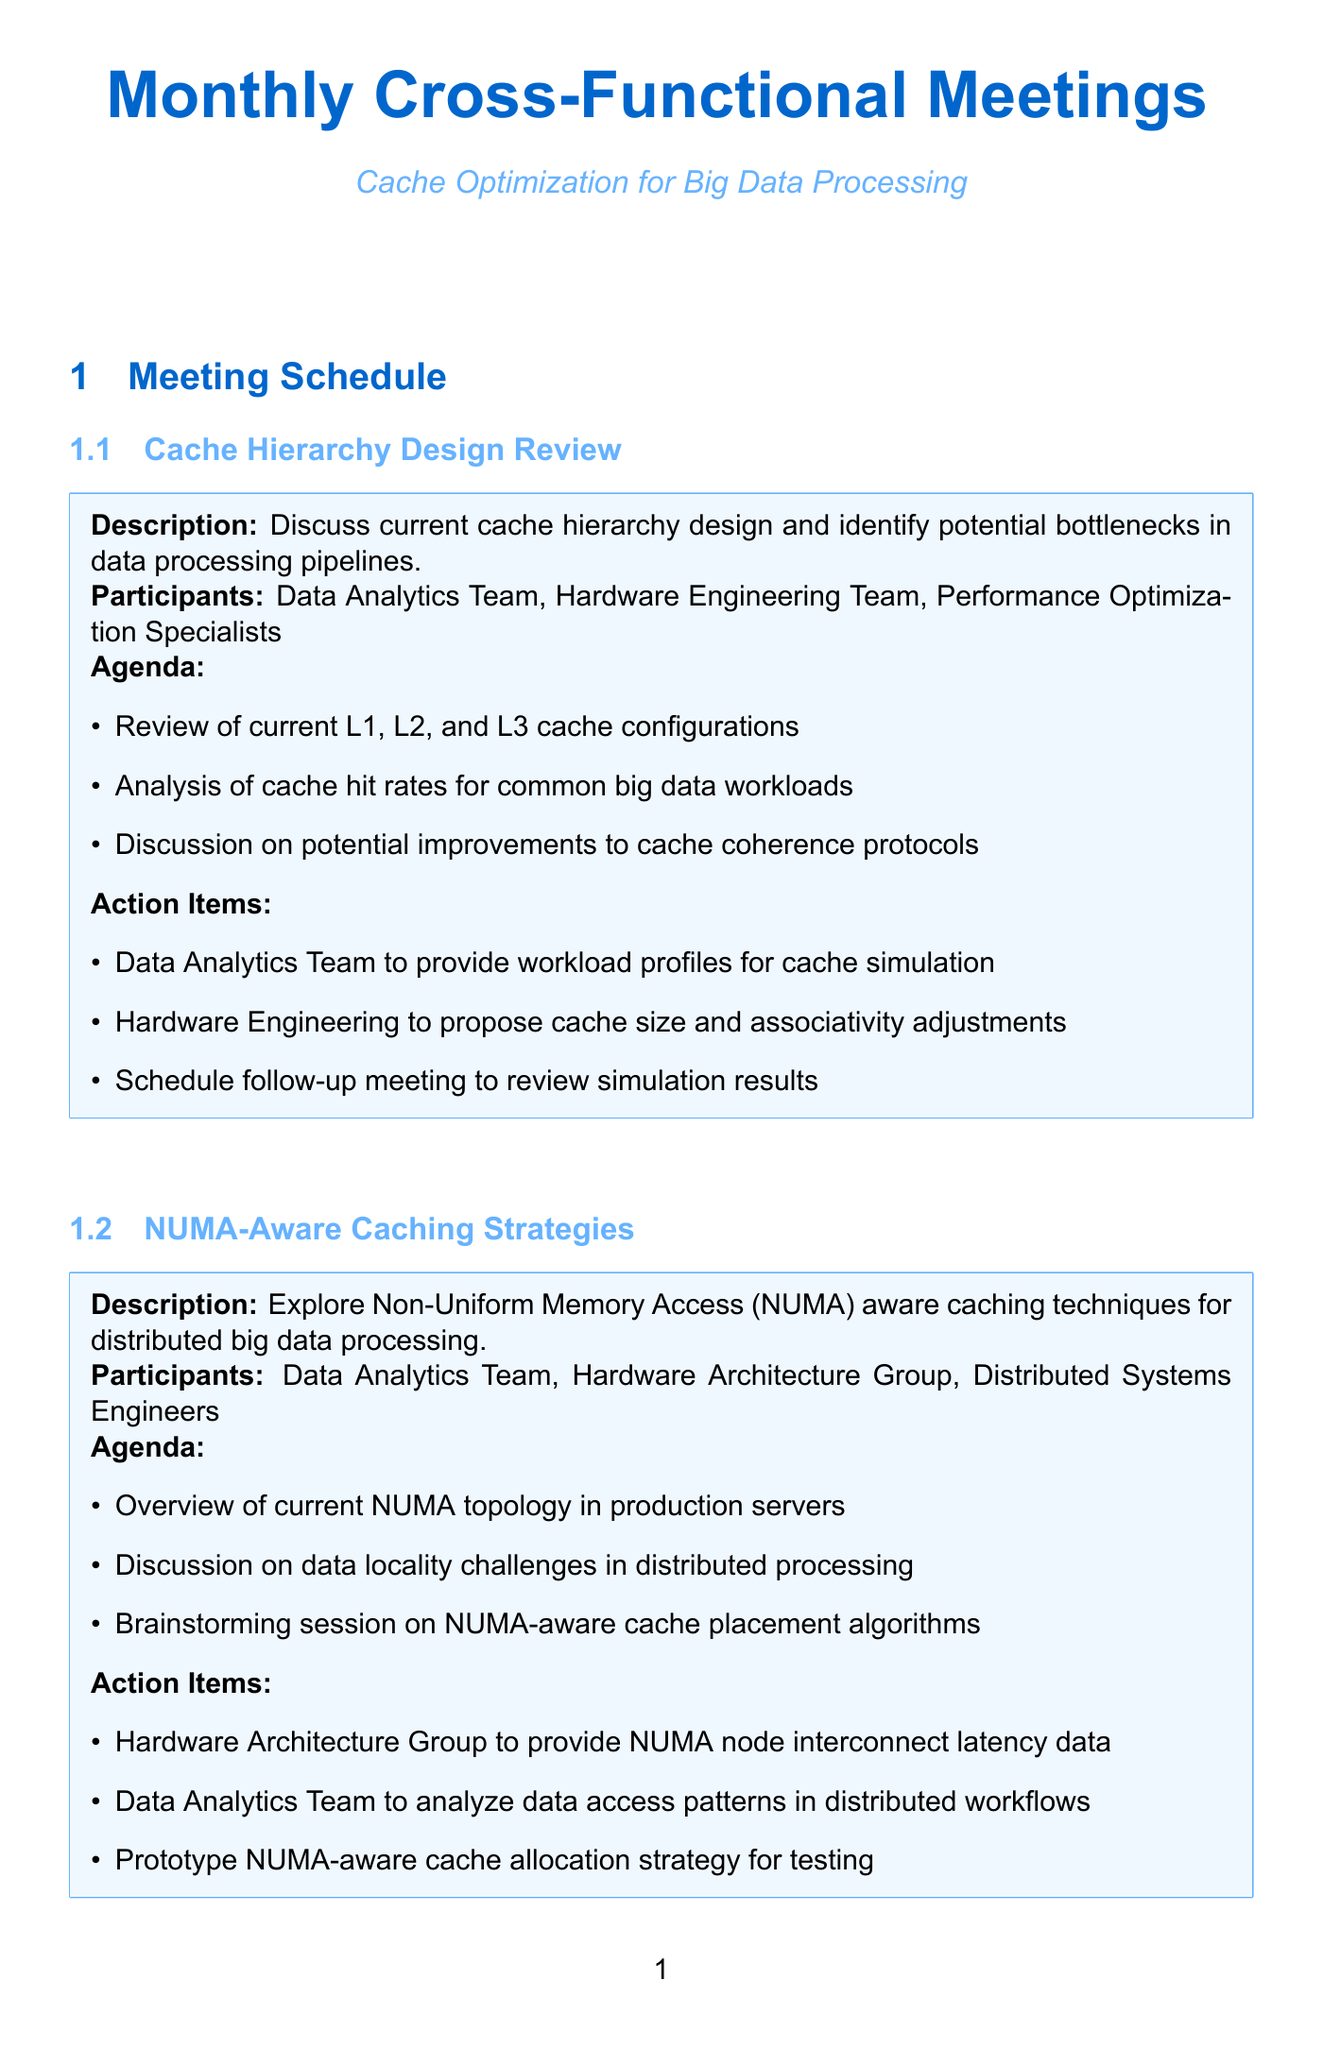What is the title of the first meeting? The title of the first meeting is the first item listed under the meeting schedule.
Answer: Cache Hierarchy Design Review Who are the participants in the "NUMA-Aware Caching Strategies" meeting? The participants are outlined under the meeting title in bullet points.
Answer: Data Analytics Team, Hardware Architecture Group, Distributed Systems Engineers What is one action item for the "Cache Prefetching Optimization" meeting? The action items are listed under the description of the "Cache Prefetching Optimization" meeting.
Answer: Data Analytics Team to provide sample query workloads for prefetch analysis How many meetings are listed in the schedule? The total number of meetings can be counted from the sections in the document.
Answer: Six What does the "Cache Coherence Protocol Enhancements" meeting aim to discuss? The aim is detailed in the description section beneath the meeting title.
Answer: Improvements to cache coherence protocols for better performance in multi-socket systems Which team is responsible for providing NUMA node interconnect latency data? This information is found in the action items of the "NUMA-Aware Caching Strategies" meeting.
Answer: Hardware Architecture Group What is the main focus of the "Cache Partitioning for Multitenancy" meeting? The focus is described in the meeting's title and further detailed in the description.
Answer: Cache partitioning strategies to support multitenancy in shared big data processing environments What is one agenda item for the "Software-Defined Caching Strategies" meeting? The agenda items are listed in bullet points under this meeting.
Answer: Review of current software caching layers (e.g., Memcached, Redis) 